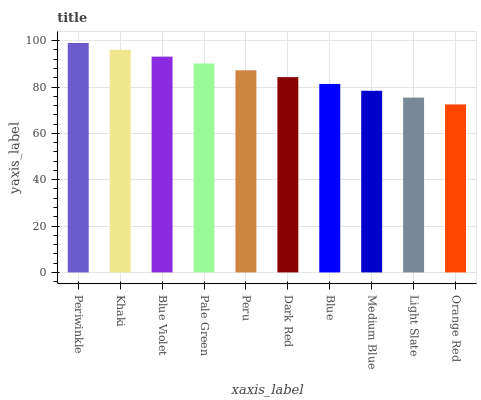Is Periwinkle the maximum?
Answer yes or no. Yes. Is Khaki the minimum?
Answer yes or no. No. Is Khaki the maximum?
Answer yes or no. No. Is Periwinkle greater than Khaki?
Answer yes or no. Yes. Is Khaki less than Periwinkle?
Answer yes or no. Yes. Is Khaki greater than Periwinkle?
Answer yes or no. No. Is Periwinkle less than Khaki?
Answer yes or no. No. Is Peru the high median?
Answer yes or no. Yes. Is Dark Red the low median?
Answer yes or no. Yes. Is Orange Red the high median?
Answer yes or no. No. Is Medium Blue the low median?
Answer yes or no. No. 